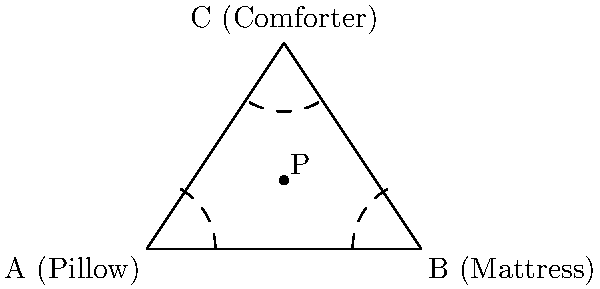In a non-Euclidean bedding space, points A, B, and C represent a pillow, mattress, and comforter respectively. Point P is equidistant from all three points. If the distance between A and B is 2 units, what is the approximate distance between P and any of the three bedding items, assuming the space follows the curvature of a sphere? To solve this problem, we need to understand how distance is measured differently in a non-Euclidean space, specifically on a sphere:

1. In Euclidean geometry, P would be at the center of the circle inscribed in the triangle. However, on a sphere, the concept of "equidistant" changes.

2. On a sphere, the shortest path between two points (geodesic) is an arc of a great circle, not a straight line.

3. The sum of the angles in a spherical triangle is always greater than 180°. This excess is related to the area of the triangle on the sphere.

4. We can use the spherical law of cosines to calculate distances on a sphere.

5. Given that A and B are 2 units apart on the surface of the sphere, we can estimate the radius of the sphere using the formula:
   $R = \frac{d}{\theta}$, where d is the arc length (2 units) and θ is the central angle in radians.

6. Assuming a relatively small triangle on the sphere, we can approximate θ to be about 0.2 radians (about 11.5°).

7. This gives us an estimated sphere radius of $R = \frac{2}{0.2} = 10$ units.

8. The equidistant point P on a sphere forms equal angles with the vertices of the triangle. These angles are approximately 120° each.

9. Using the spherical law of cosines:
   $\cos(c) = \cos(a)\cos(b) + \sin(a)\sin(b)\cos(C)$
   Where c is the arc length we're looking for, a and b are π/3 (60°), and C is 2π/3 (120°).

10. Solving this equation gives us $c \approx 1.15$ radians.

11. Converting this back to arc length on our sphere:
    $\text{Distance} = R \cdot c = 10 \cdot 1.15 \approx 11.5$ units

Therefore, the approximate distance between P and any of the three bedding items in this non-Euclidean space is about 11.5 units.
Answer: 11.5 units 